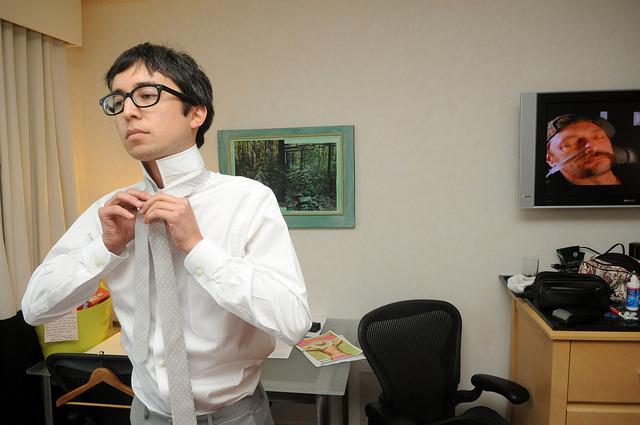Is the television turned on?
Short answer required. Yes. Is he getting married?
Give a very brief answer. No. Does the man have a large belt buckle?
Short answer required. No. What is the man tying?
Keep it brief. Tie. 